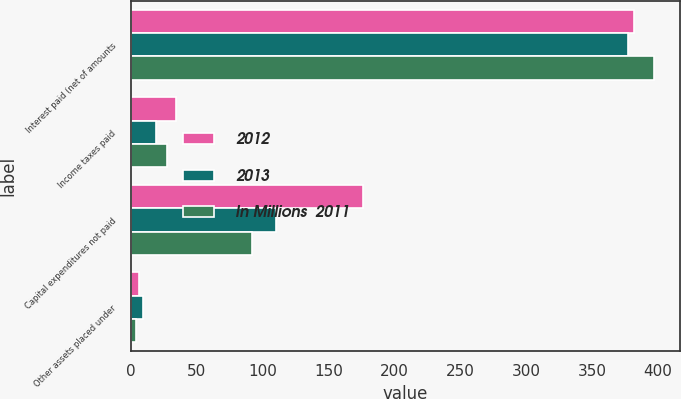Convert chart. <chart><loc_0><loc_0><loc_500><loc_500><stacked_bar_chart><ecel><fcel>Interest paid (net of amounts<fcel>Income taxes paid<fcel>Capital expenditures not paid<fcel>Other assets placed under<nl><fcel>2012<fcel>382<fcel>34<fcel>176<fcel>6<nl><fcel>2013<fcel>377<fcel>19<fcel>110<fcel>9<nl><fcel>In Millions  2011<fcel>397<fcel>27<fcel>92<fcel>4<nl></chart> 